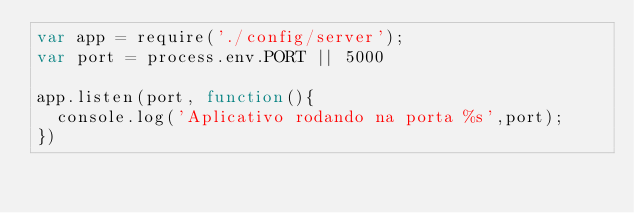Convert code to text. <code><loc_0><loc_0><loc_500><loc_500><_JavaScript_>var app = require('./config/server');
var port = process.env.PORT || 5000

app.listen(port, function(){
  console.log('Aplicativo rodando na porta %s',port);
})
</code> 